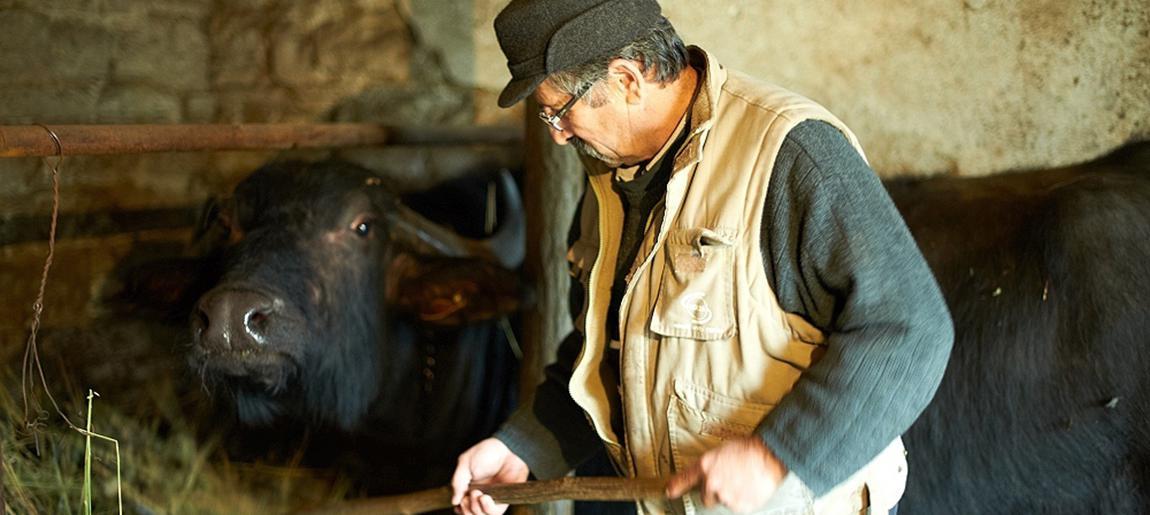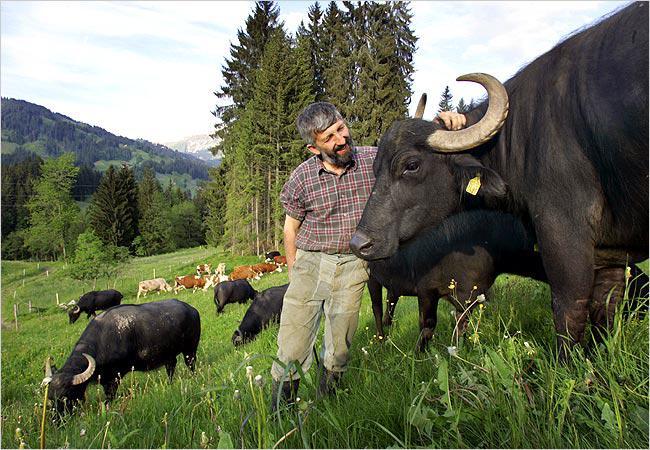The first image is the image on the left, the second image is the image on the right. For the images displayed, is the sentence "The right image contains at least one water buffalo walking through a town on a dirt road." factually correct? Answer yes or no. No. The first image is the image on the left, the second image is the image on the right. Analyze the images presented: Is the assertion "In at least one image, water buffalo are walking rightward down a street lined with buildings." valid? Answer yes or no. No. 